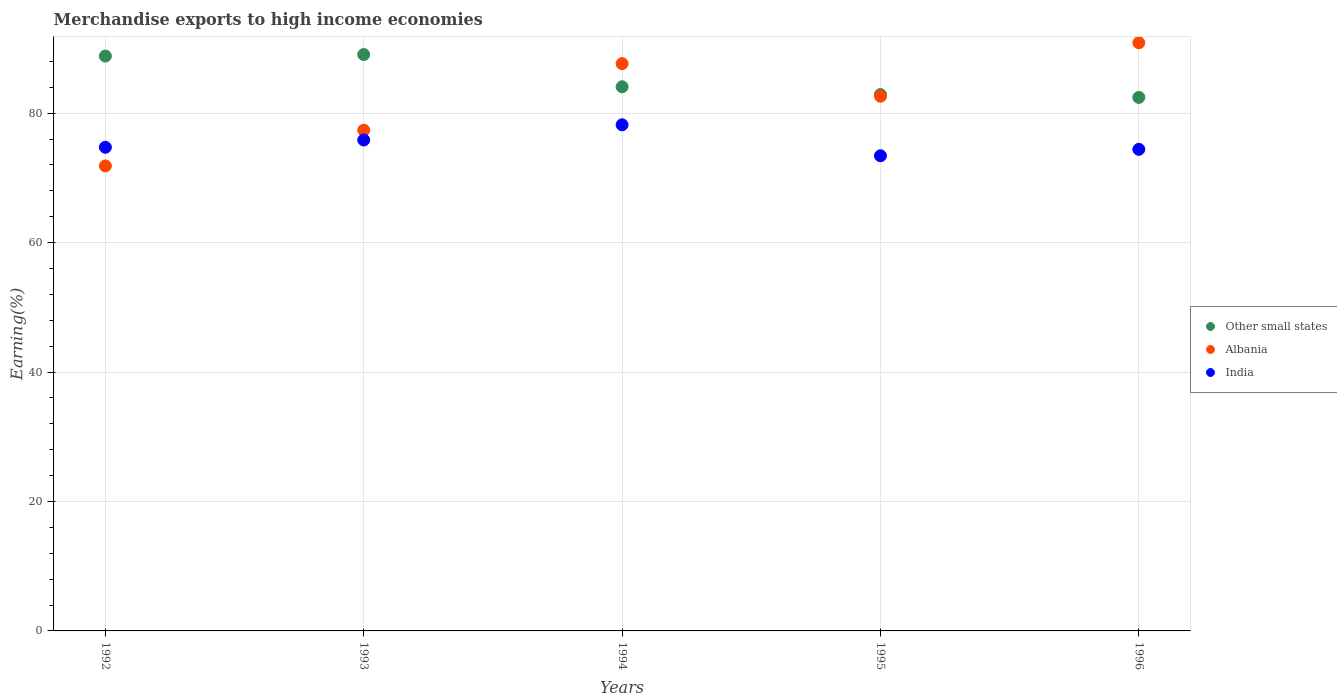How many different coloured dotlines are there?
Ensure brevity in your answer.  3. Is the number of dotlines equal to the number of legend labels?
Your response must be concise. Yes. What is the percentage of amount earned from merchandise exports in Albania in 1996?
Give a very brief answer. 90.89. Across all years, what is the maximum percentage of amount earned from merchandise exports in Other small states?
Your answer should be very brief. 89.06. Across all years, what is the minimum percentage of amount earned from merchandise exports in Albania?
Your response must be concise. 71.85. In which year was the percentage of amount earned from merchandise exports in Other small states minimum?
Provide a short and direct response. 1996. What is the total percentage of amount earned from merchandise exports in Albania in the graph?
Your response must be concise. 410.38. What is the difference between the percentage of amount earned from merchandise exports in India in 1993 and that in 1994?
Offer a very short reply. -2.35. What is the difference between the percentage of amount earned from merchandise exports in Albania in 1994 and the percentage of amount earned from merchandise exports in Other small states in 1995?
Provide a succinct answer. 4.78. What is the average percentage of amount earned from merchandise exports in Other small states per year?
Your answer should be compact. 85.46. In the year 1993, what is the difference between the percentage of amount earned from merchandise exports in India and percentage of amount earned from merchandise exports in Albania?
Provide a short and direct response. -1.52. In how many years, is the percentage of amount earned from merchandise exports in Albania greater than 68 %?
Your answer should be very brief. 5. What is the ratio of the percentage of amount earned from merchandise exports in India in 1994 to that in 1996?
Ensure brevity in your answer.  1.05. Is the percentage of amount earned from merchandise exports in Other small states in 1992 less than that in 1996?
Ensure brevity in your answer.  No. What is the difference between the highest and the second highest percentage of amount earned from merchandise exports in Other small states?
Keep it short and to the point. 0.24. What is the difference between the highest and the lowest percentage of amount earned from merchandise exports in Other small states?
Ensure brevity in your answer.  6.62. Is the sum of the percentage of amount earned from merchandise exports in Albania in 1992 and 1995 greater than the maximum percentage of amount earned from merchandise exports in Other small states across all years?
Offer a very short reply. Yes. Is it the case that in every year, the sum of the percentage of amount earned from merchandise exports in Other small states and percentage of amount earned from merchandise exports in Albania  is greater than the percentage of amount earned from merchandise exports in India?
Offer a very short reply. Yes. How many dotlines are there?
Offer a terse response. 3. How many years are there in the graph?
Ensure brevity in your answer.  5. What is the difference between two consecutive major ticks on the Y-axis?
Make the answer very short. 20. Are the values on the major ticks of Y-axis written in scientific E-notation?
Make the answer very short. No. Does the graph contain any zero values?
Provide a short and direct response. No. How are the legend labels stacked?
Keep it short and to the point. Vertical. What is the title of the graph?
Your answer should be very brief. Merchandise exports to high income economies. Does "Iran" appear as one of the legend labels in the graph?
Give a very brief answer. No. What is the label or title of the X-axis?
Give a very brief answer. Years. What is the label or title of the Y-axis?
Your answer should be compact. Earning(%). What is the Earning(%) in Other small states in 1992?
Your response must be concise. 88.82. What is the Earning(%) in Albania in 1992?
Give a very brief answer. 71.85. What is the Earning(%) in India in 1992?
Provide a short and direct response. 74.73. What is the Earning(%) in Other small states in 1993?
Your answer should be very brief. 89.06. What is the Earning(%) in Albania in 1993?
Keep it short and to the point. 77.37. What is the Earning(%) in India in 1993?
Your answer should be compact. 75.85. What is the Earning(%) of Other small states in 1994?
Your answer should be compact. 84.08. What is the Earning(%) of Albania in 1994?
Offer a terse response. 87.66. What is the Earning(%) in India in 1994?
Provide a short and direct response. 78.21. What is the Earning(%) of Other small states in 1995?
Give a very brief answer. 82.88. What is the Earning(%) of Albania in 1995?
Offer a terse response. 82.61. What is the Earning(%) in India in 1995?
Offer a terse response. 73.42. What is the Earning(%) in Other small states in 1996?
Give a very brief answer. 82.44. What is the Earning(%) of Albania in 1996?
Your answer should be compact. 90.89. What is the Earning(%) of India in 1996?
Your answer should be very brief. 74.41. Across all years, what is the maximum Earning(%) of Other small states?
Provide a succinct answer. 89.06. Across all years, what is the maximum Earning(%) of Albania?
Your response must be concise. 90.89. Across all years, what is the maximum Earning(%) of India?
Your response must be concise. 78.21. Across all years, what is the minimum Earning(%) in Other small states?
Provide a short and direct response. 82.44. Across all years, what is the minimum Earning(%) in Albania?
Your answer should be very brief. 71.85. Across all years, what is the minimum Earning(%) of India?
Give a very brief answer. 73.42. What is the total Earning(%) in Other small states in the graph?
Make the answer very short. 427.28. What is the total Earning(%) in Albania in the graph?
Ensure brevity in your answer.  410.38. What is the total Earning(%) of India in the graph?
Your answer should be very brief. 376.63. What is the difference between the Earning(%) in Other small states in 1992 and that in 1993?
Your answer should be very brief. -0.24. What is the difference between the Earning(%) of Albania in 1992 and that in 1993?
Keep it short and to the point. -5.52. What is the difference between the Earning(%) in India in 1992 and that in 1993?
Offer a very short reply. -1.12. What is the difference between the Earning(%) in Other small states in 1992 and that in 1994?
Keep it short and to the point. 4.74. What is the difference between the Earning(%) in Albania in 1992 and that in 1994?
Give a very brief answer. -15.81. What is the difference between the Earning(%) of India in 1992 and that in 1994?
Make the answer very short. -3.47. What is the difference between the Earning(%) of Other small states in 1992 and that in 1995?
Your response must be concise. 5.94. What is the difference between the Earning(%) of Albania in 1992 and that in 1995?
Make the answer very short. -10.76. What is the difference between the Earning(%) of India in 1992 and that in 1995?
Provide a short and direct response. 1.31. What is the difference between the Earning(%) of Other small states in 1992 and that in 1996?
Your answer should be very brief. 6.39. What is the difference between the Earning(%) of Albania in 1992 and that in 1996?
Provide a short and direct response. -19.03. What is the difference between the Earning(%) of India in 1992 and that in 1996?
Offer a terse response. 0.32. What is the difference between the Earning(%) in Other small states in 1993 and that in 1994?
Your answer should be compact. 4.98. What is the difference between the Earning(%) of Albania in 1993 and that in 1994?
Provide a succinct answer. -10.28. What is the difference between the Earning(%) in India in 1993 and that in 1994?
Keep it short and to the point. -2.35. What is the difference between the Earning(%) of Other small states in 1993 and that in 1995?
Your response must be concise. 6.18. What is the difference between the Earning(%) in Albania in 1993 and that in 1995?
Ensure brevity in your answer.  -5.24. What is the difference between the Earning(%) of India in 1993 and that in 1995?
Your response must be concise. 2.44. What is the difference between the Earning(%) in Other small states in 1993 and that in 1996?
Your answer should be compact. 6.62. What is the difference between the Earning(%) of Albania in 1993 and that in 1996?
Keep it short and to the point. -13.51. What is the difference between the Earning(%) of India in 1993 and that in 1996?
Make the answer very short. 1.44. What is the difference between the Earning(%) in Other small states in 1994 and that in 1995?
Provide a succinct answer. 1.2. What is the difference between the Earning(%) of Albania in 1994 and that in 1995?
Offer a terse response. 5.05. What is the difference between the Earning(%) in India in 1994 and that in 1995?
Offer a terse response. 4.79. What is the difference between the Earning(%) in Other small states in 1994 and that in 1996?
Your answer should be compact. 1.65. What is the difference between the Earning(%) of Albania in 1994 and that in 1996?
Your answer should be compact. -3.23. What is the difference between the Earning(%) of India in 1994 and that in 1996?
Offer a very short reply. 3.79. What is the difference between the Earning(%) of Other small states in 1995 and that in 1996?
Offer a terse response. 0.45. What is the difference between the Earning(%) of Albania in 1995 and that in 1996?
Offer a terse response. -8.27. What is the difference between the Earning(%) of India in 1995 and that in 1996?
Offer a terse response. -1. What is the difference between the Earning(%) in Other small states in 1992 and the Earning(%) in Albania in 1993?
Make the answer very short. 11.45. What is the difference between the Earning(%) in Other small states in 1992 and the Earning(%) in India in 1993?
Provide a short and direct response. 12.97. What is the difference between the Earning(%) of Albania in 1992 and the Earning(%) of India in 1993?
Ensure brevity in your answer.  -4. What is the difference between the Earning(%) of Other small states in 1992 and the Earning(%) of Albania in 1994?
Your answer should be very brief. 1.16. What is the difference between the Earning(%) in Other small states in 1992 and the Earning(%) in India in 1994?
Offer a very short reply. 10.62. What is the difference between the Earning(%) in Albania in 1992 and the Earning(%) in India in 1994?
Your answer should be very brief. -6.36. What is the difference between the Earning(%) of Other small states in 1992 and the Earning(%) of Albania in 1995?
Provide a succinct answer. 6.21. What is the difference between the Earning(%) of Other small states in 1992 and the Earning(%) of India in 1995?
Offer a very short reply. 15.4. What is the difference between the Earning(%) in Albania in 1992 and the Earning(%) in India in 1995?
Your answer should be very brief. -1.57. What is the difference between the Earning(%) of Other small states in 1992 and the Earning(%) of Albania in 1996?
Provide a succinct answer. -2.06. What is the difference between the Earning(%) in Other small states in 1992 and the Earning(%) in India in 1996?
Make the answer very short. 14.41. What is the difference between the Earning(%) of Albania in 1992 and the Earning(%) of India in 1996?
Your answer should be compact. -2.56. What is the difference between the Earning(%) of Other small states in 1993 and the Earning(%) of Albania in 1994?
Provide a succinct answer. 1.4. What is the difference between the Earning(%) in Other small states in 1993 and the Earning(%) in India in 1994?
Provide a succinct answer. 10.85. What is the difference between the Earning(%) of Albania in 1993 and the Earning(%) of India in 1994?
Give a very brief answer. -0.83. What is the difference between the Earning(%) in Other small states in 1993 and the Earning(%) in Albania in 1995?
Offer a very short reply. 6.45. What is the difference between the Earning(%) of Other small states in 1993 and the Earning(%) of India in 1995?
Offer a terse response. 15.64. What is the difference between the Earning(%) of Albania in 1993 and the Earning(%) of India in 1995?
Offer a terse response. 3.96. What is the difference between the Earning(%) of Other small states in 1993 and the Earning(%) of Albania in 1996?
Offer a terse response. -1.83. What is the difference between the Earning(%) of Other small states in 1993 and the Earning(%) of India in 1996?
Ensure brevity in your answer.  14.65. What is the difference between the Earning(%) of Albania in 1993 and the Earning(%) of India in 1996?
Provide a short and direct response. 2.96. What is the difference between the Earning(%) in Other small states in 1994 and the Earning(%) in Albania in 1995?
Offer a very short reply. 1.47. What is the difference between the Earning(%) in Other small states in 1994 and the Earning(%) in India in 1995?
Give a very brief answer. 10.66. What is the difference between the Earning(%) of Albania in 1994 and the Earning(%) of India in 1995?
Offer a terse response. 14.24. What is the difference between the Earning(%) of Other small states in 1994 and the Earning(%) of Albania in 1996?
Your response must be concise. -6.8. What is the difference between the Earning(%) of Other small states in 1994 and the Earning(%) of India in 1996?
Give a very brief answer. 9.67. What is the difference between the Earning(%) of Albania in 1994 and the Earning(%) of India in 1996?
Give a very brief answer. 13.24. What is the difference between the Earning(%) of Other small states in 1995 and the Earning(%) of Albania in 1996?
Offer a very short reply. -8. What is the difference between the Earning(%) in Other small states in 1995 and the Earning(%) in India in 1996?
Provide a short and direct response. 8.47. What is the difference between the Earning(%) in Albania in 1995 and the Earning(%) in India in 1996?
Give a very brief answer. 8.2. What is the average Earning(%) of Other small states per year?
Offer a terse response. 85.46. What is the average Earning(%) of Albania per year?
Make the answer very short. 82.08. What is the average Earning(%) in India per year?
Provide a short and direct response. 75.33. In the year 1992, what is the difference between the Earning(%) in Other small states and Earning(%) in Albania?
Keep it short and to the point. 16.97. In the year 1992, what is the difference between the Earning(%) in Other small states and Earning(%) in India?
Provide a succinct answer. 14.09. In the year 1992, what is the difference between the Earning(%) in Albania and Earning(%) in India?
Your answer should be very brief. -2.88. In the year 1993, what is the difference between the Earning(%) in Other small states and Earning(%) in Albania?
Your answer should be very brief. 11.69. In the year 1993, what is the difference between the Earning(%) of Other small states and Earning(%) of India?
Offer a terse response. 13.21. In the year 1993, what is the difference between the Earning(%) in Albania and Earning(%) in India?
Ensure brevity in your answer.  1.52. In the year 1994, what is the difference between the Earning(%) of Other small states and Earning(%) of Albania?
Offer a terse response. -3.58. In the year 1994, what is the difference between the Earning(%) of Other small states and Earning(%) of India?
Your response must be concise. 5.87. In the year 1994, what is the difference between the Earning(%) of Albania and Earning(%) of India?
Your answer should be very brief. 9.45. In the year 1995, what is the difference between the Earning(%) of Other small states and Earning(%) of Albania?
Ensure brevity in your answer.  0.27. In the year 1995, what is the difference between the Earning(%) of Other small states and Earning(%) of India?
Give a very brief answer. 9.46. In the year 1995, what is the difference between the Earning(%) in Albania and Earning(%) in India?
Your answer should be compact. 9.19. In the year 1996, what is the difference between the Earning(%) of Other small states and Earning(%) of Albania?
Provide a short and direct response. -8.45. In the year 1996, what is the difference between the Earning(%) of Other small states and Earning(%) of India?
Provide a succinct answer. 8.02. In the year 1996, what is the difference between the Earning(%) of Albania and Earning(%) of India?
Offer a very short reply. 16.47. What is the ratio of the Earning(%) of India in 1992 to that in 1993?
Offer a very short reply. 0.99. What is the ratio of the Earning(%) of Other small states in 1992 to that in 1994?
Your answer should be very brief. 1.06. What is the ratio of the Earning(%) of Albania in 1992 to that in 1994?
Make the answer very short. 0.82. What is the ratio of the Earning(%) in India in 1992 to that in 1994?
Ensure brevity in your answer.  0.96. What is the ratio of the Earning(%) in Other small states in 1992 to that in 1995?
Make the answer very short. 1.07. What is the ratio of the Earning(%) of Albania in 1992 to that in 1995?
Your response must be concise. 0.87. What is the ratio of the Earning(%) of India in 1992 to that in 1995?
Provide a short and direct response. 1.02. What is the ratio of the Earning(%) in Other small states in 1992 to that in 1996?
Your answer should be very brief. 1.08. What is the ratio of the Earning(%) in Albania in 1992 to that in 1996?
Offer a very short reply. 0.79. What is the ratio of the Earning(%) of Other small states in 1993 to that in 1994?
Offer a terse response. 1.06. What is the ratio of the Earning(%) of Albania in 1993 to that in 1994?
Your answer should be very brief. 0.88. What is the ratio of the Earning(%) in India in 1993 to that in 1994?
Offer a terse response. 0.97. What is the ratio of the Earning(%) in Other small states in 1993 to that in 1995?
Ensure brevity in your answer.  1.07. What is the ratio of the Earning(%) of Albania in 1993 to that in 1995?
Offer a terse response. 0.94. What is the ratio of the Earning(%) of India in 1993 to that in 1995?
Your response must be concise. 1.03. What is the ratio of the Earning(%) of Other small states in 1993 to that in 1996?
Offer a very short reply. 1.08. What is the ratio of the Earning(%) in Albania in 1993 to that in 1996?
Offer a terse response. 0.85. What is the ratio of the Earning(%) of India in 1993 to that in 1996?
Your answer should be compact. 1.02. What is the ratio of the Earning(%) in Other small states in 1994 to that in 1995?
Your answer should be very brief. 1.01. What is the ratio of the Earning(%) in Albania in 1994 to that in 1995?
Offer a very short reply. 1.06. What is the ratio of the Earning(%) in India in 1994 to that in 1995?
Provide a short and direct response. 1.07. What is the ratio of the Earning(%) in Albania in 1994 to that in 1996?
Offer a very short reply. 0.96. What is the ratio of the Earning(%) in India in 1994 to that in 1996?
Keep it short and to the point. 1.05. What is the ratio of the Earning(%) in Other small states in 1995 to that in 1996?
Offer a terse response. 1.01. What is the ratio of the Earning(%) in Albania in 1995 to that in 1996?
Your answer should be very brief. 0.91. What is the ratio of the Earning(%) in India in 1995 to that in 1996?
Provide a short and direct response. 0.99. What is the difference between the highest and the second highest Earning(%) in Other small states?
Provide a short and direct response. 0.24. What is the difference between the highest and the second highest Earning(%) of Albania?
Give a very brief answer. 3.23. What is the difference between the highest and the second highest Earning(%) in India?
Keep it short and to the point. 2.35. What is the difference between the highest and the lowest Earning(%) in Other small states?
Provide a succinct answer. 6.62. What is the difference between the highest and the lowest Earning(%) of Albania?
Offer a very short reply. 19.03. What is the difference between the highest and the lowest Earning(%) in India?
Make the answer very short. 4.79. 